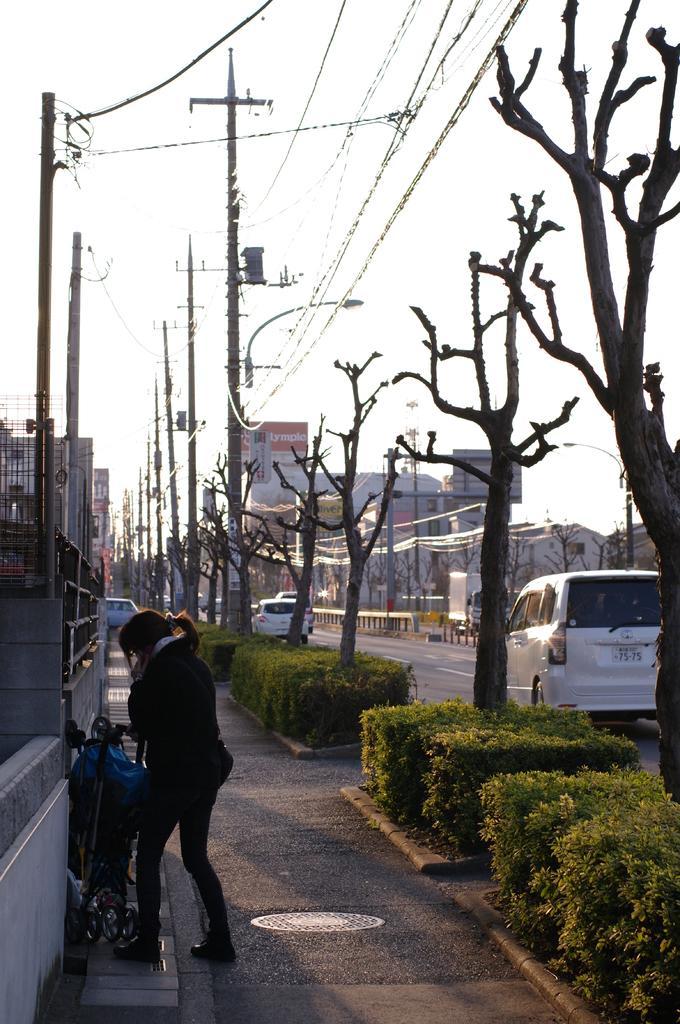Please provide a concise description of this image. In this image there are a few vehicles on the road, few buildings, streetlights, electric poles and cables, a person standing on the pavement, garden plants, a few trees without leaves and the sky. 